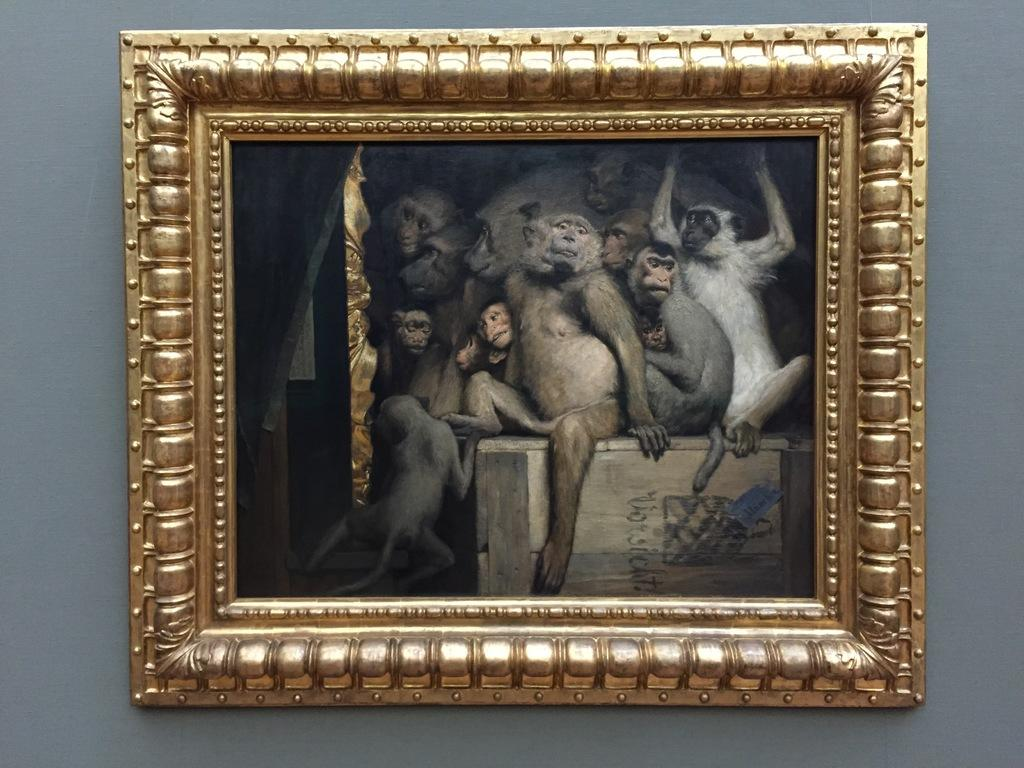What is the main subject in the center of the image? There is a photo frame in the center of the image. What is depicted inside the photo frame? The photo frame contains many monkeys. What can be seen in the background of the image? There is a wall in the background of the image. Who is the owner of the vacation reward in the image? There is no vacation reward or owner mentioned in the image; it only features a photo frame with monkeys. 